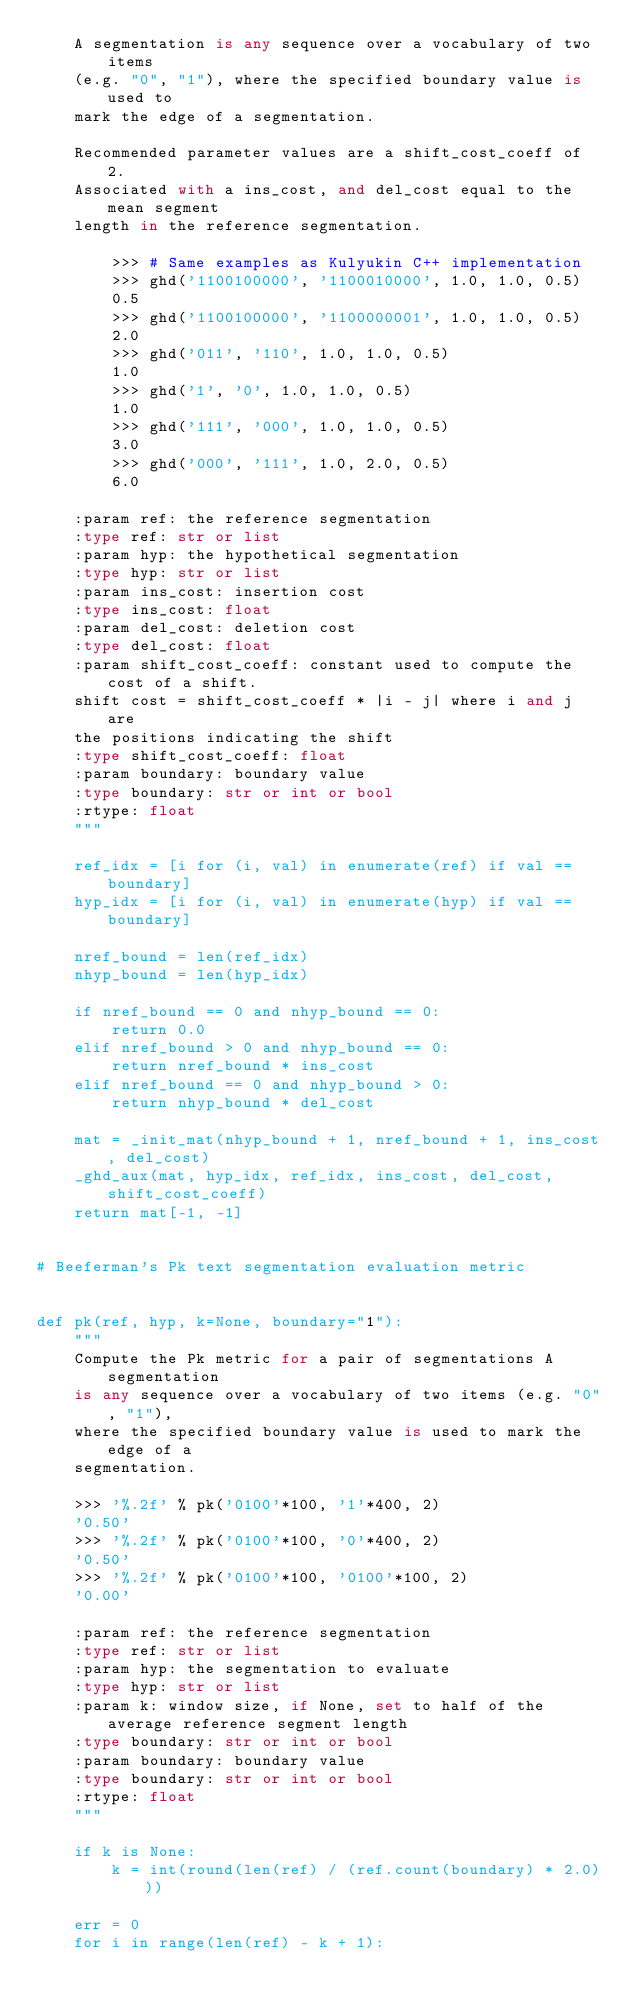<code> <loc_0><loc_0><loc_500><loc_500><_Python_>    A segmentation is any sequence over a vocabulary of two items
    (e.g. "0", "1"), where the specified boundary value is used to
    mark the edge of a segmentation.

    Recommended parameter values are a shift_cost_coeff of 2.
    Associated with a ins_cost, and del_cost equal to the mean segment
    length in the reference segmentation.

        >>> # Same examples as Kulyukin C++ implementation
        >>> ghd('1100100000', '1100010000', 1.0, 1.0, 0.5)
        0.5
        >>> ghd('1100100000', '1100000001', 1.0, 1.0, 0.5)
        2.0
        >>> ghd('011', '110', 1.0, 1.0, 0.5)
        1.0
        >>> ghd('1', '0', 1.0, 1.0, 0.5)
        1.0
        >>> ghd('111', '000', 1.0, 1.0, 0.5)
        3.0
        >>> ghd('000', '111', 1.0, 2.0, 0.5)
        6.0

    :param ref: the reference segmentation
    :type ref: str or list
    :param hyp: the hypothetical segmentation
    :type hyp: str or list
    :param ins_cost: insertion cost
    :type ins_cost: float
    :param del_cost: deletion cost
    :type del_cost: float
    :param shift_cost_coeff: constant used to compute the cost of a shift.
    shift cost = shift_cost_coeff * |i - j| where i and j are
    the positions indicating the shift
    :type shift_cost_coeff: float
    :param boundary: boundary value
    :type boundary: str or int or bool
    :rtype: float
    """

    ref_idx = [i for (i, val) in enumerate(ref) if val == boundary]
    hyp_idx = [i for (i, val) in enumerate(hyp) if val == boundary]

    nref_bound = len(ref_idx)
    nhyp_bound = len(hyp_idx)

    if nref_bound == 0 and nhyp_bound == 0:
        return 0.0
    elif nref_bound > 0 and nhyp_bound == 0:
        return nref_bound * ins_cost
    elif nref_bound == 0 and nhyp_bound > 0:
        return nhyp_bound * del_cost

    mat = _init_mat(nhyp_bound + 1, nref_bound + 1, ins_cost, del_cost)
    _ghd_aux(mat, hyp_idx, ref_idx, ins_cost, del_cost, shift_cost_coeff)
    return mat[-1, -1]


# Beeferman's Pk text segmentation evaluation metric


def pk(ref, hyp, k=None, boundary="1"):
    """
    Compute the Pk metric for a pair of segmentations A segmentation
    is any sequence over a vocabulary of two items (e.g. "0", "1"),
    where the specified boundary value is used to mark the edge of a
    segmentation.

    >>> '%.2f' % pk('0100'*100, '1'*400, 2)
    '0.50'
    >>> '%.2f' % pk('0100'*100, '0'*400, 2)
    '0.50'
    >>> '%.2f' % pk('0100'*100, '0100'*100, 2)
    '0.00'

    :param ref: the reference segmentation
    :type ref: str or list
    :param hyp: the segmentation to evaluate
    :type hyp: str or list
    :param k: window size, if None, set to half of the average reference segment length
    :type boundary: str or int or bool
    :param boundary: boundary value
    :type boundary: str or int or bool
    :rtype: float
    """

    if k is None:
        k = int(round(len(ref) / (ref.count(boundary) * 2.0)))

    err = 0
    for i in range(len(ref) - k + 1):</code> 